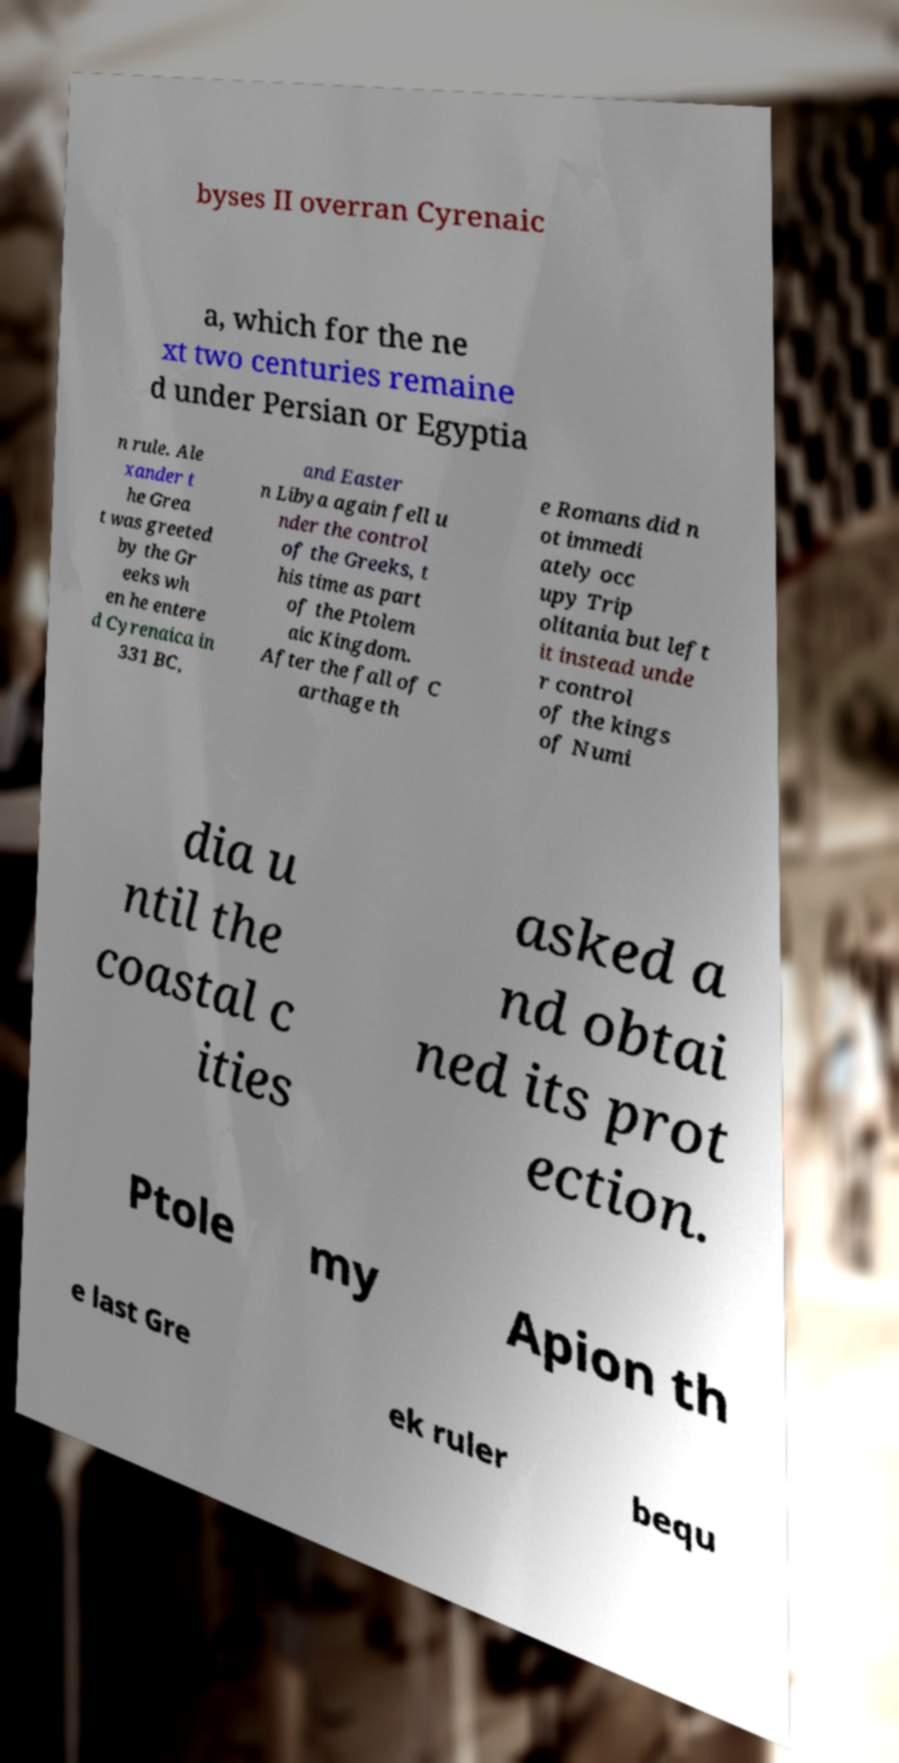Can you accurately transcribe the text from the provided image for me? byses II overran Cyrenaic a, which for the ne xt two centuries remaine d under Persian or Egyptia n rule. Ale xander t he Grea t was greeted by the Gr eeks wh en he entere d Cyrenaica in 331 BC, and Easter n Libya again fell u nder the control of the Greeks, t his time as part of the Ptolem aic Kingdom. After the fall of C arthage th e Romans did n ot immedi ately occ upy Trip olitania but left it instead unde r control of the kings of Numi dia u ntil the coastal c ities asked a nd obtai ned its prot ection. Ptole my Apion th e last Gre ek ruler bequ 